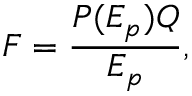Convert formula to latex. <formula><loc_0><loc_0><loc_500><loc_500>F = \frac { P ( E _ { p } ) Q } { E _ { p } } ,</formula> 